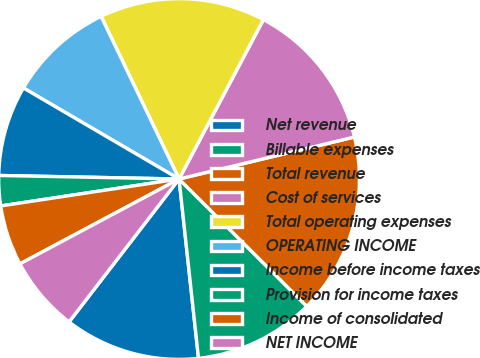<chart> <loc_0><loc_0><loc_500><loc_500><pie_chart><fcel>Net revenue<fcel>Billable expenses<fcel>Total revenue<fcel>Cost of services<fcel>Total operating expenses<fcel>OPERATING INCOME<fcel>Income before income taxes<fcel>Provision for income taxes<fcel>Income of consolidated<fcel>NET INCOME<nl><fcel>12.16%<fcel>10.81%<fcel>16.21%<fcel>13.51%<fcel>14.86%<fcel>9.46%<fcel>8.11%<fcel>2.7%<fcel>5.41%<fcel>6.76%<nl></chart> 